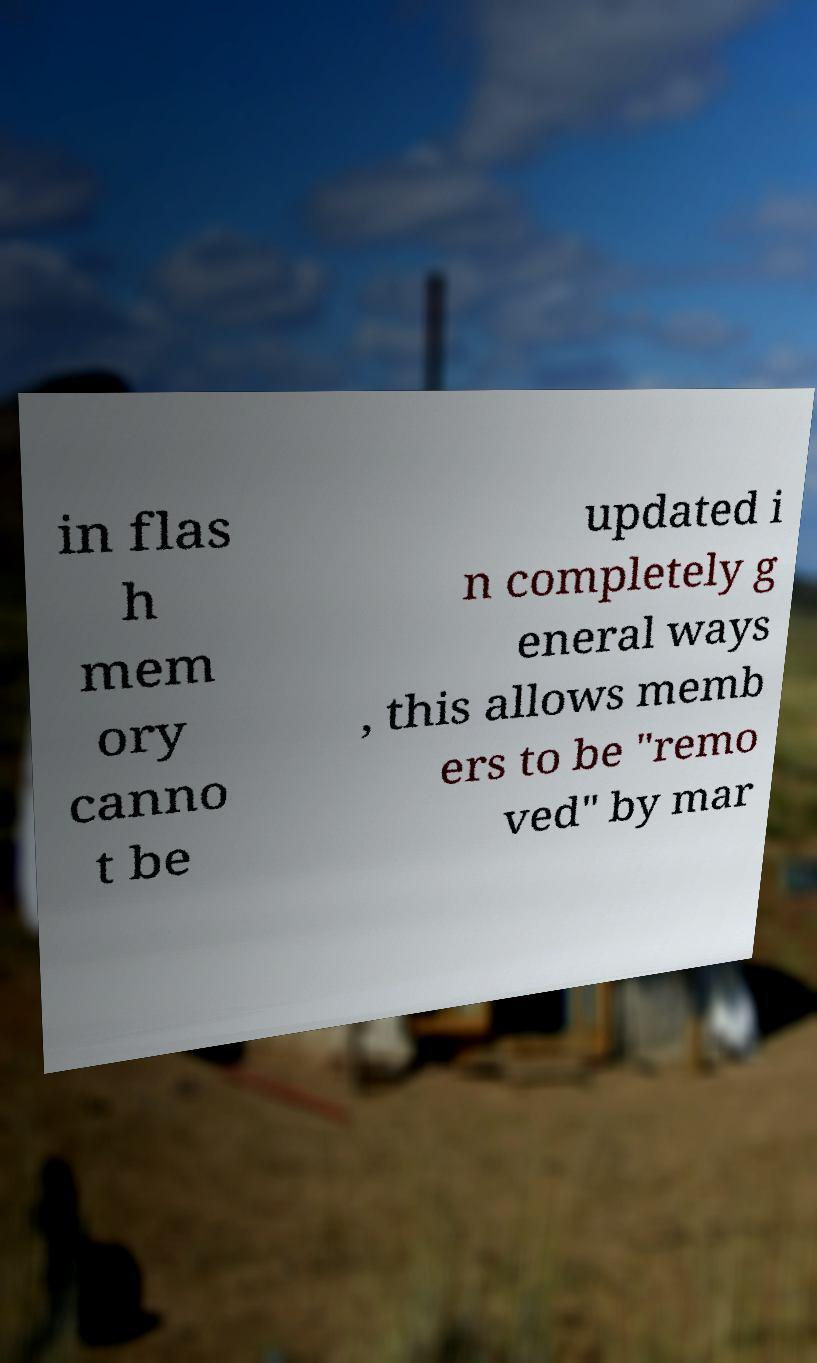Please identify and transcribe the text found in this image. in flas h mem ory canno t be updated i n completely g eneral ways , this allows memb ers to be "remo ved" by mar 